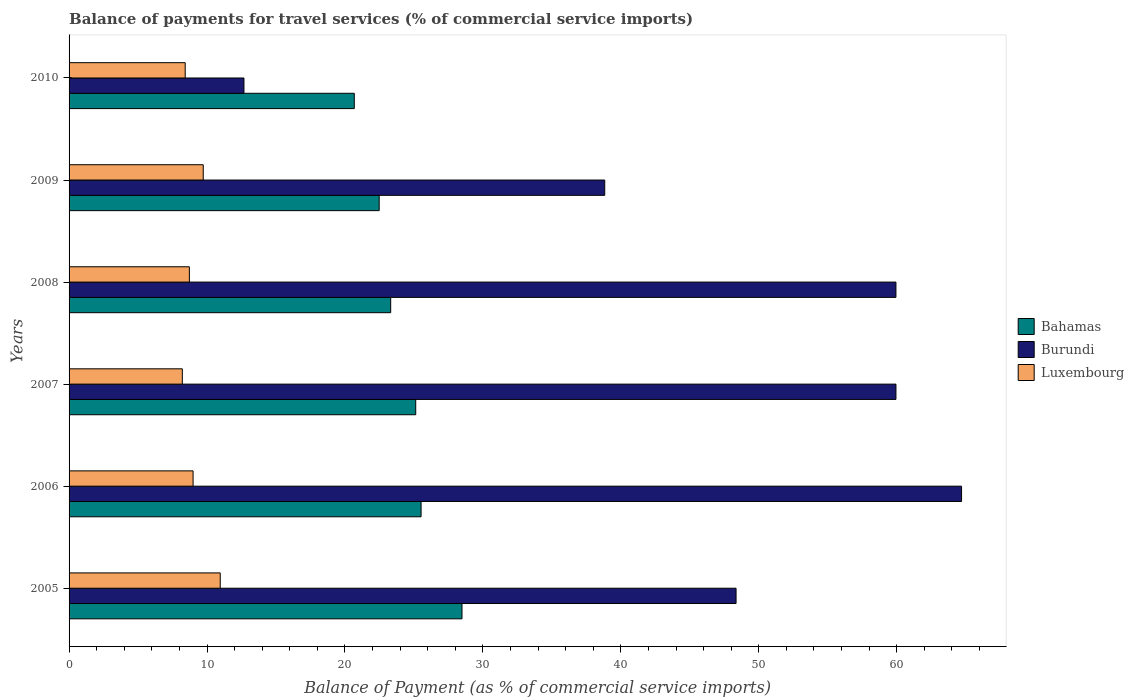How many different coloured bars are there?
Ensure brevity in your answer.  3. Are the number of bars per tick equal to the number of legend labels?
Your answer should be compact. Yes. Are the number of bars on each tick of the Y-axis equal?
Your response must be concise. Yes. How many bars are there on the 4th tick from the bottom?
Your answer should be compact. 3. What is the label of the 3rd group of bars from the top?
Make the answer very short. 2008. In how many cases, is the number of bars for a given year not equal to the number of legend labels?
Provide a succinct answer. 0. What is the balance of payments for travel services in Bahamas in 2005?
Make the answer very short. 28.49. Across all years, what is the maximum balance of payments for travel services in Luxembourg?
Provide a succinct answer. 10.96. Across all years, what is the minimum balance of payments for travel services in Burundi?
Provide a short and direct response. 12.68. What is the total balance of payments for travel services in Luxembourg in the graph?
Make the answer very short. 55.03. What is the difference between the balance of payments for travel services in Bahamas in 2008 and that in 2010?
Offer a very short reply. 2.64. What is the difference between the balance of payments for travel services in Luxembourg in 2010 and the balance of payments for travel services in Bahamas in 2008?
Your answer should be compact. -14.9. What is the average balance of payments for travel services in Luxembourg per year?
Ensure brevity in your answer.  9.17. In the year 2007, what is the difference between the balance of payments for travel services in Bahamas and balance of payments for travel services in Burundi?
Provide a succinct answer. -34.81. In how many years, is the balance of payments for travel services in Luxembourg greater than 40 %?
Your response must be concise. 0. What is the ratio of the balance of payments for travel services in Luxembourg in 2007 to that in 2008?
Provide a short and direct response. 0.94. Is the balance of payments for travel services in Luxembourg in 2005 less than that in 2009?
Make the answer very short. No. Is the difference between the balance of payments for travel services in Bahamas in 2005 and 2008 greater than the difference between the balance of payments for travel services in Burundi in 2005 and 2008?
Ensure brevity in your answer.  Yes. What is the difference between the highest and the second highest balance of payments for travel services in Burundi?
Provide a succinct answer. 4.76. What is the difference between the highest and the lowest balance of payments for travel services in Bahamas?
Provide a short and direct response. 7.81. In how many years, is the balance of payments for travel services in Burundi greater than the average balance of payments for travel services in Burundi taken over all years?
Your answer should be compact. 4. Is the sum of the balance of payments for travel services in Burundi in 2005 and 2006 greater than the maximum balance of payments for travel services in Bahamas across all years?
Make the answer very short. Yes. What does the 1st bar from the top in 2007 represents?
Offer a very short reply. Luxembourg. What does the 3rd bar from the bottom in 2006 represents?
Your answer should be compact. Luxembourg. How many bars are there?
Your answer should be compact. 18. Are the values on the major ticks of X-axis written in scientific E-notation?
Your answer should be compact. No. Does the graph contain any zero values?
Make the answer very short. No. Does the graph contain grids?
Provide a short and direct response. No. Where does the legend appear in the graph?
Give a very brief answer. Center right. How are the legend labels stacked?
Provide a succinct answer. Vertical. What is the title of the graph?
Give a very brief answer. Balance of payments for travel services (% of commercial service imports). Does "Poland" appear as one of the legend labels in the graph?
Keep it short and to the point. No. What is the label or title of the X-axis?
Ensure brevity in your answer.  Balance of Payment (as % of commercial service imports). What is the Balance of Payment (as % of commercial service imports) in Bahamas in 2005?
Your response must be concise. 28.49. What is the Balance of Payment (as % of commercial service imports) of Burundi in 2005?
Your answer should be compact. 48.35. What is the Balance of Payment (as % of commercial service imports) of Luxembourg in 2005?
Give a very brief answer. 10.96. What is the Balance of Payment (as % of commercial service imports) in Bahamas in 2006?
Ensure brevity in your answer.  25.52. What is the Balance of Payment (as % of commercial service imports) in Burundi in 2006?
Give a very brief answer. 64.7. What is the Balance of Payment (as % of commercial service imports) of Luxembourg in 2006?
Provide a succinct answer. 8.99. What is the Balance of Payment (as % of commercial service imports) of Bahamas in 2007?
Offer a very short reply. 25.13. What is the Balance of Payment (as % of commercial service imports) in Burundi in 2007?
Offer a very short reply. 59.95. What is the Balance of Payment (as % of commercial service imports) in Luxembourg in 2007?
Provide a succinct answer. 8.21. What is the Balance of Payment (as % of commercial service imports) of Bahamas in 2008?
Provide a short and direct response. 23.32. What is the Balance of Payment (as % of commercial service imports) in Burundi in 2008?
Give a very brief answer. 59.94. What is the Balance of Payment (as % of commercial service imports) of Luxembourg in 2008?
Keep it short and to the point. 8.72. What is the Balance of Payment (as % of commercial service imports) in Bahamas in 2009?
Provide a short and direct response. 22.48. What is the Balance of Payment (as % of commercial service imports) in Burundi in 2009?
Provide a succinct answer. 38.83. What is the Balance of Payment (as % of commercial service imports) of Luxembourg in 2009?
Your response must be concise. 9.73. What is the Balance of Payment (as % of commercial service imports) in Bahamas in 2010?
Provide a succinct answer. 20.68. What is the Balance of Payment (as % of commercial service imports) of Burundi in 2010?
Your answer should be very brief. 12.68. What is the Balance of Payment (as % of commercial service imports) in Luxembourg in 2010?
Ensure brevity in your answer.  8.42. Across all years, what is the maximum Balance of Payment (as % of commercial service imports) in Bahamas?
Keep it short and to the point. 28.49. Across all years, what is the maximum Balance of Payment (as % of commercial service imports) of Burundi?
Ensure brevity in your answer.  64.7. Across all years, what is the maximum Balance of Payment (as % of commercial service imports) of Luxembourg?
Make the answer very short. 10.96. Across all years, what is the minimum Balance of Payment (as % of commercial service imports) of Bahamas?
Your answer should be compact. 20.68. Across all years, what is the minimum Balance of Payment (as % of commercial service imports) of Burundi?
Give a very brief answer. 12.68. Across all years, what is the minimum Balance of Payment (as % of commercial service imports) of Luxembourg?
Your answer should be very brief. 8.21. What is the total Balance of Payment (as % of commercial service imports) of Bahamas in the graph?
Give a very brief answer. 145.61. What is the total Balance of Payment (as % of commercial service imports) of Burundi in the graph?
Your answer should be compact. 284.46. What is the total Balance of Payment (as % of commercial service imports) in Luxembourg in the graph?
Offer a very short reply. 55.03. What is the difference between the Balance of Payment (as % of commercial service imports) in Bahamas in 2005 and that in 2006?
Make the answer very short. 2.97. What is the difference between the Balance of Payment (as % of commercial service imports) in Burundi in 2005 and that in 2006?
Offer a terse response. -16.35. What is the difference between the Balance of Payment (as % of commercial service imports) of Luxembourg in 2005 and that in 2006?
Offer a very short reply. 1.97. What is the difference between the Balance of Payment (as % of commercial service imports) in Bahamas in 2005 and that in 2007?
Provide a succinct answer. 3.36. What is the difference between the Balance of Payment (as % of commercial service imports) in Burundi in 2005 and that in 2007?
Offer a terse response. -11.59. What is the difference between the Balance of Payment (as % of commercial service imports) in Luxembourg in 2005 and that in 2007?
Give a very brief answer. 2.75. What is the difference between the Balance of Payment (as % of commercial service imports) in Bahamas in 2005 and that in 2008?
Your answer should be compact. 5.17. What is the difference between the Balance of Payment (as % of commercial service imports) in Burundi in 2005 and that in 2008?
Ensure brevity in your answer.  -11.59. What is the difference between the Balance of Payment (as % of commercial service imports) in Luxembourg in 2005 and that in 2008?
Your answer should be very brief. 2.24. What is the difference between the Balance of Payment (as % of commercial service imports) of Bahamas in 2005 and that in 2009?
Your answer should be compact. 6. What is the difference between the Balance of Payment (as % of commercial service imports) of Burundi in 2005 and that in 2009?
Your answer should be compact. 9.52. What is the difference between the Balance of Payment (as % of commercial service imports) in Luxembourg in 2005 and that in 2009?
Make the answer very short. 1.23. What is the difference between the Balance of Payment (as % of commercial service imports) in Bahamas in 2005 and that in 2010?
Provide a succinct answer. 7.81. What is the difference between the Balance of Payment (as % of commercial service imports) of Burundi in 2005 and that in 2010?
Keep it short and to the point. 35.68. What is the difference between the Balance of Payment (as % of commercial service imports) of Luxembourg in 2005 and that in 2010?
Your answer should be very brief. 2.54. What is the difference between the Balance of Payment (as % of commercial service imports) in Bahamas in 2006 and that in 2007?
Provide a succinct answer. 0.39. What is the difference between the Balance of Payment (as % of commercial service imports) in Burundi in 2006 and that in 2007?
Keep it short and to the point. 4.76. What is the difference between the Balance of Payment (as % of commercial service imports) of Luxembourg in 2006 and that in 2007?
Give a very brief answer. 0.78. What is the difference between the Balance of Payment (as % of commercial service imports) of Bahamas in 2006 and that in 2008?
Your answer should be compact. 2.2. What is the difference between the Balance of Payment (as % of commercial service imports) in Burundi in 2006 and that in 2008?
Give a very brief answer. 4.76. What is the difference between the Balance of Payment (as % of commercial service imports) of Luxembourg in 2006 and that in 2008?
Keep it short and to the point. 0.27. What is the difference between the Balance of Payment (as % of commercial service imports) of Bahamas in 2006 and that in 2009?
Give a very brief answer. 3.04. What is the difference between the Balance of Payment (as % of commercial service imports) in Burundi in 2006 and that in 2009?
Your response must be concise. 25.87. What is the difference between the Balance of Payment (as % of commercial service imports) of Luxembourg in 2006 and that in 2009?
Ensure brevity in your answer.  -0.74. What is the difference between the Balance of Payment (as % of commercial service imports) in Bahamas in 2006 and that in 2010?
Provide a short and direct response. 4.84. What is the difference between the Balance of Payment (as % of commercial service imports) of Burundi in 2006 and that in 2010?
Your answer should be very brief. 52.02. What is the difference between the Balance of Payment (as % of commercial service imports) in Luxembourg in 2006 and that in 2010?
Ensure brevity in your answer.  0.57. What is the difference between the Balance of Payment (as % of commercial service imports) in Bahamas in 2007 and that in 2008?
Keep it short and to the point. 1.81. What is the difference between the Balance of Payment (as % of commercial service imports) of Burundi in 2007 and that in 2008?
Your answer should be compact. 0. What is the difference between the Balance of Payment (as % of commercial service imports) in Luxembourg in 2007 and that in 2008?
Provide a short and direct response. -0.51. What is the difference between the Balance of Payment (as % of commercial service imports) of Bahamas in 2007 and that in 2009?
Your answer should be compact. 2.65. What is the difference between the Balance of Payment (as % of commercial service imports) in Burundi in 2007 and that in 2009?
Your response must be concise. 21.11. What is the difference between the Balance of Payment (as % of commercial service imports) in Luxembourg in 2007 and that in 2009?
Provide a succinct answer. -1.51. What is the difference between the Balance of Payment (as % of commercial service imports) of Bahamas in 2007 and that in 2010?
Give a very brief answer. 4.45. What is the difference between the Balance of Payment (as % of commercial service imports) in Burundi in 2007 and that in 2010?
Provide a short and direct response. 47.27. What is the difference between the Balance of Payment (as % of commercial service imports) of Luxembourg in 2007 and that in 2010?
Ensure brevity in your answer.  -0.21. What is the difference between the Balance of Payment (as % of commercial service imports) of Bahamas in 2008 and that in 2009?
Ensure brevity in your answer.  0.83. What is the difference between the Balance of Payment (as % of commercial service imports) in Burundi in 2008 and that in 2009?
Provide a short and direct response. 21.11. What is the difference between the Balance of Payment (as % of commercial service imports) of Luxembourg in 2008 and that in 2009?
Your response must be concise. -1. What is the difference between the Balance of Payment (as % of commercial service imports) in Bahamas in 2008 and that in 2010?
Ensure brevity in your answer.  2.64. What is the difference between the Balance of Payment (as % of commercial service imports) in Burundi in 2008 and that in 2010?
Offer a terse response. 47.27. What is the difference between the Balance of Payment (as % of commercial service imports) of Luxembourg in 2008 and that in 2010?
Provide a short and direct response. 0.3. What is the difference between the Balance of Payment (as % of commercial service imports) of Bahamas in 2009 and that in 2010?
Offer a terse response. 1.81. What is the difference between the Balance of Payment (as % of commercial service imports) in Burundi in 2009 and that in 2010?
Offer a terse response. 26.16. What is the difference between the Balance of Payment (as % of commercial service imports) of Luxembourg in 2009 and that in 2010?
Ensure brevity in your answer.  1.31. What is the difference between the Balance of Payment (as % of commercial service imports) of Bahamas in 2005 and the Balance of Payment (as % of commercial service imports) of Burundi in 2006?
Give a very brief answer. -36.22. What is the difference between the Balance of Payment (as % of commercial service imports) of Bahamas in 2005 and the Balance of Payment (as % of commercial service imports) of Luxembourg in 2006?
Offer a very short reply. 19.5. What is the difference between the Balance of Payment (as % of commercial service imports) of Burundi in 2005 and the Balance of Payment (as % of commercial service imports) of Luxembourg in 2006?
Keep it short and to the point. 39.36. What is the difference between the Balance of Payment (as % of commercial service imports) of Bahamas in 2005 and the Balance of Payment (as % of commercial service imports) of Burundi in 2007?
Ensure brevity in your answer.  -31.46. What is the difference between the Balance of Payment (as % of commercial service imports) in Bahamas in 2005 and the Balance of Payment (as % of commercial service imports) in Luxembourg in 2007?
Provide a short and direct response. 20.27. What is the difference between the Balance of Payment (as % of commercial service imports) of Burundi in 2005 and the Balance of Payment (as % of commercial service imports) of Luxembourg in 2007?
Keep it short and to the point. 40.14. What is the difference between the Balance of Payment (as % of commercial service imports) of Bahamas in 2005 and the Balance of Payment (as % of commercial service imports) of Burundi in 2008?
Give a very brief answer. -31.46. What is the difference between the Balance of Payment (as % of commercial service imports) in Bahamas in 2005 and the Balance of Payment (as % of commercial service imports) in Luxembourg in 2008?
Keep it short and to the point. 19.76. What is the difference between the Balance of Payment (as % of commercial service imports) of Burundi in 2005 and the Balance of Payment (as % of commercial service imports) of Luxembourg in 2008?
Offer a terse response. 39.63. What is the difference between the Balance of Payment (as % of commercial service imports) in Bahamas in 2005 and the Balance of Payment (as % of commercial service imports) in Burundi in 2009?
Ensure brevity in your answer.  -10.35. What is the difference between the Balance of Payment (as % of commercial service imports) of Bahamas in 2005 and the Balance of Payment (as % of commercial service imports) of Luxembourg in 2009?
Provide a succinct answer. 18.76. What is the difference between the Balance of Payment (as % of commercial service imports) of Burundi in 2005 and the Balance of Payment (as % of commercial service imports) of Luxembourg in 2009?
Make the answer very short. 38.63. What is the difference between the Balance of Payment (as % of commercial service imports) in Bahamas in 2005 and the Balance of Payment (as % of commercial service imports) in Burundi in 2010?
Your answer should be very brief. 15.81. What is the difference between the Balance of Payment (as % of commercial service imports) in Bahamas in 2005 and the Balance of Payment (as % of commercial service imports) in Luxembourg in 2010?
Provide a succinct answer. 20.07. What is the difference between the Balance of Payment (as % of commercial service imports) in Burundi in 2005 and the Balance of Payment (as % of commercial service imports) in Luxembourg in 2010?
Make the answer very short. 39.94. What is the difference between the Balance of Payment (as % of commercial service imports) of Bahamas in 2006 and the Balance of Payment (as % of commercial service imports) of Burundi in 2007?
Your answer should be very brief. -34.43. What is the difference between the Balance of Payment (as % of commercial service imports) in Bahamas in 2006 and the Balance of Payment (as % of commercial service imports) in Luxembourg in 2007?
Ensure brevity in your answer.  17.31. What is the difference between the Balance of Payment (as % of commercial service imports) in Burundi in 2006 and the Balance of Payment (as % of commercial service imports) in Luxembourg in 2007?
Offer a terse response. 56.49. What is the difference between the Balance of Payment (as % of commercial service imports) in Bahamas in 2006 and the Balance of Payment (as % of commercial service imports) in Burundi in 2008?
Make the answer very short. -34.42. What is the difference between the Balance of Payment (as % of commercial service imports) of Bahamas in 2006 and the Balance of Payment (as % of commercial service imports) of Luxembourg in 2008?
Your answer should be very brief. 16.8. What is the difference between the Balance of Payment (as % of commercial service imports) of Burundi in 2006 and the Balance of Payment (as % of commercial service imports) of Luxembourg in 2008?
Your answer should be very brief. 55.98. What is the difference between the Balance of Payment (as % of commercial service imports) of Bahamas in 2006 and the Balance of Payment (as % of commercial service imports) of Burundi in 2009?
Your answer should be compact. -13.31. What is the difference between the Balance of Payment (as % of commercial service imports) of Bahamas in 2006 and the Balance of Payment (as % of commercial service imports) of Luxembourg in 2009?
Make the answer very short. 15.79. What is the difference between the Balance of Payment (as % of commercial service imports) in Burundi in 2006 and the Balance of Payment (as % of commercial service imports) in Luxembourg in 2009?
Your answer should be very brief. 54.98. What is the difference between the Balance of Payment (as % of commercial service imports) in Bahamas in 2006 and the Balance of Payment (as % of commercial service imports) in Burundi in 2010?
Keep it short and to the point. 12.84. What is the difference between the Balance of Payment (as % of commercial service imports) of Bahamas in 2006 and the Balance of Payment (as % of commercial service imports) of Luxembourg in 2010?
Ensure brevity in your answer.  17.1. What is the difference between the Balance of Payment (as % of commercial service imports) of Burundi in 2006 and the Balance of Payment (as % of commercial service imports) of Luxembourg in 2010?
Keep it short and to the point. 56.28. What is the difference between the Balance of Payment (as % of commercial service imports) of Bahamas in 2007 and the Balance of Payment (as % of commercial service imports) of Burundi in 2008?
Your answer should be compact. -34.81. What is the difference between the Balance of Payment (as % of commercial service imports) of Bahamas in 2007 and the Balance of Payment (as % of commercial service imports) of Luxembourg in 2008?
Provide a succinct answer. 16.41. What is the difference between the Balance of Payment (as % of commercial service imports) of Burundi in 2007 and the Balance of Payment (as % of commercial service imports) of Luxembourg in 2008?
Your response must be concise. 51.22. What is the difference between the Balance of Payment (as % of commercial service imports) in Bahamas in 2007 and the Balance of Payment (as % of commercial service imports) in Burundi in 2009?
Your answer should be compact. -13.7. What is the difference between the Balance of Payment (as % of commercial service imports) of Bahamas in 2007 and the Balance of Payment (as % of commercial service imports) of Luxembourg in 2009?
Provide a succinct answer. 15.4. What is the difference between the Balance of Payment (as % of commercial service imports) in Burundi in 2007 and the Balance of Payment (as % of commercial service imports) in Luxembourg in 2009?
Provide a succinct answer. 50.22. What is the difference between the Balance of Payment (as % of commercial service imports) of Bahamas in 2007 and the Balance of Payment (as % of commercial service imports) of Burundi in 2010?
Offer a very short reply. 12.45. What is the difference between the Balance of Payment (as % of commercial service imports) of Bahamas in 2007 and the Balance of Payment (as % of commercial service imports) of Luxembourg in 2010?
Offer a very short reply. 16.71. What is the difference between the Balance of Payment (as % of commercial service imports) in Burundi in 2007 and the Balance of Payment (as % of commercial service imports) in Luxembourg in 2010?
Your response must be concise. 51.53. What is the difference between the Balance of Payment (as % of commercial service imports) of Bahamas in 2008 and the Balance of Payment (as % of commercial service imports) of Burundi in 2009?
Your answer should be compact. -15.52. What is the difference between the Balance of Payment (as % of commercial service imports) of Bahamas in 2008 and the Balance of Payment (as % of commercial service imports) of Luxembourg in 2009?
Keep it short and to the point. 13.59. What is the difference between the Balance of Payment (as % of commercial service imports) in Burundi in 2008 and the Balance of Payment (as % of commercial service imports) in Luxembourg in 2009?
Your response must be concise. 50.22. What is the difference between the Balance of Payment (as % of commercial service imports) in Bahamas in 2008 and the Balance of Payment (as % of commercial service imports) in Burundi in 2010?
Offer a very short reply. 10.64. What is the difference between the Balance of Payment (as % of commercial service imports) in Bahamas in 2008 and the Balance of Payment (as % of commercial service imports) in Luxembourg in 2010?
Offer a terse response. 14.9. What is the difference between the Balance of Payment (as % of commercial service imports) in Burundi in 2008 and the Balance of Payment (as % of commercial service imports) in Luxembourg in 2010?
Make the answer very short. 51.52. What is the difference between the Balance of Payment (as % of commercial service imports) in Bahamas in 2009 and the Balance of Payment (as % of commercial service imports) in Burundi in 2010?
Ensure brevity in your answer.  9.8. What is the difference between the Balance of Payment (as % of commercial service imports) of Bahamas in 2009 and the Balance of Payment (as % of commercial service imports) of Luxembourg in 2010?
Provide a succinct answer. 14.06. What is the difference between the Balance of Payment (as % of commercial service imports) in Burundi in 2009 and the Balance of Payment (as % of commercial service imports) in Luxembourg in 2010?
Ensure brevity in your answer.  30.41. What is the average Balance of Payment (as % of commercial service imports) in Bahamas per year?
Offer a terse response. 24.27. What is the average Balance of Payment (as % of commercial service imports) of Burundi per year?
Give a very brief answer. 47.41. What is the average Balance of Payment (as % of commercial service imports) of Luxembourg per year?
Offer a terse response. 9.17. In the year 2005, what is the difference between the Balance of Payment (as % of commercial service imports) of Bahamas and Balance of Payment (as % of commercial service imports) of Burundi?
Provide a succinct answer. -19.87. In the year 2005, what is the difference between the Balance of Payment (as % of commercial service imports) of Bahamas and Balance of Payment (as % of commercial service imports) of Luxembourg?
Ensure brevity in your answer.  17.53. In the year 2005, what is the difference between the Balance of Payment (as % of commercial service imports) of Burundi and Balance of Payment (as % of commercial service imports) of Luxembourg?
Your answer should be very brief. 37.4. In the year 2006, what is the difference between the Balance of Payment (as % of commercial service imports) in Bahamas and Balance of Payment (as % of commercial service imports) in Burundi?
Ensure brevity in your answer.  -39.18. In the year 2006, what is the difference between the Balance of Payment (as % of commercial service imports) of Bahamas and Balance of Payment (as % of commercial service imports) of Luxembourg?
Keep it short and to the point. 16.53. In the year 2006, what is the difference between the Balance of Payment (as % of commercial service imports) of Burundi and Balance of Payment (as % of commercial service imports) of Luxembourg?
Your response must be concise. 55.71. In the year 2007, what is the difference between the Balance of Payment (as % of commercial service imports) in Bahamas and Balance of Payment (as % of commercial service imports) in Burundi?
Your answer should be very brief. -34.81. In the year 2007, what is the difference between the Balance of Payment (as % of commercial service imports) of Bahamas and Balance of Payment (as % of commercial service imports) of Luxembourg?
Provide a short and direct response. 16.92. In the year 2007, what is the difference between the Balance of Payment (as % of commercial service imports) in Burundi and Balance of Payment (as % of commercial service imports) in Luxembourg?
Offer a very short reply. 51.73. In the year 2008, what is the difference between the Balance of Payment (as % of commercial service imports) of Bahamas and Balance of Payment (as % of commercial service imports) of Burundi?
Ensure brevity in your answer.  -36.63. In the year 2008, what is the difference between the Balance of Payment (as % of commercial service imports) of Bahamas and Balance of Payment (as % of commercial service imports) of Luxembourg?
Ensure brevity in your answer.  14.59. In the year 2008, what is the difference between the Balance of Payment (as % of commercial service imports) in Burundi and Balance of Payment (as % of commercial service imports) in Luxembourg?
Provide a succinct answer. 51.22. In the year 2009, what is the difference between the Balance of Payment (as % of commercial service imports) in Bahamas and Balance of Payment (as % of commercial service imports) in Burundi?
Your answer should be very brief. -16.35. In the year 2009, what is the difference between the Balance of Payment (as % of commercial service imports) of Bahamas and Balance of Payment (as % of commercial service imports) of Luxembourg?
Your answer should be compact. 12.76. In the year 2009, what is the difference between the Balance of Payment (as % of commercial service imports) in Burundi and Balance of Payment (as % of commercial service imports) in Luxembourg?
Give a very brief answer. 29.11. In the year 2010, what is the difference between the Balance of Payment (as % of commercial service imports) of Bahamas and Balance of Payment (as % of commercial service imports) of Burundi?
Make the answer very short. 8. In the year 2010, what is the difference between the Balance of Payment (as % of commercial service imports) in Bahamas and Balance of Payment (as % of commercial service imports) in Luxembourg?
Your answer should be very brief. 12.26. In the year 2010, what is the difference between the Balance of Payment (as % of commercial service imports) of Burundi and Balance of Payment (as % of commercial service imports) of Luxembourg?
Provide a succinct answer. 4.26. What is the ratio of the Balance of Payment (as % of commercial service imports) of Bahamas in 2005 to that in 2006?
Give a very brief answer. 1.12. What is the ratio of the Balance of Payment (as % of commercial service imports) in Burundi in 2005 to that in 2006?
Keep it short and to the point. 0.75. What is the ratio of the Balance of Payment (as % of commercial service imports) of Luxembourg in 2005 to that in 2006?
Ensure brevity in your answer.  1.22. What is the ratio of the Balance of Payment (as % of commercial service imports) in Bahamas in 2005 to that in 2007?
Your answer should be compact. 1.13. What is the ratio of the Balance of Payment (as % of commercial service imports) in Burundi in 2005 to that in 2007?
Keep it short and to the point. 0.81. What is the ratio of the Balance of Payment (as % of commercial service imports) of Luxembourg in 2005 to that in 2007?
Offer a very short reply. 1.33. What is the ratio of the Balance of Payment (as % of commercial service imports) in Bahamas in 2005 to that in 2008?
Keep it short and to the point. 1.22. What is the ratio of the Balance of Payment (as % of commercial service imports) of Burundi in 2005 to that in 2008?
Ensure brevity in your answer.  0.81. What is the ratio of the Balance of Payment (as % of commercial service imports) in Luxembourg in 2005 to that in 2008?
Keep it short and to the point. 1.26. What is the ratio of the Balance of Payment (as % of commercial service imports) of Bahamas in 2005 to that in 2009?
Your response must be concise. 1.27. What is the ratio of the Balance of Payment (as % of commercial service imports) in Burundi in 2005 to that in 2009?
Your answer should be compact. 1.25. What is the ratio of the Balance of Payment (as % of commercial service imports) of Luxembourg in 2005 to that in 2009?
Your answer should be very brief. 1.13. What is the ratio of the Balance of Payment (as % of commercial service imports) in Bahamas in 2005 to that in 2010?
Ensure brevity in your answer.  1.38. What is the ratio of the Balance of Payment (as % of commercial service imports) in Burundi in 2005 to that in 2010?
Your answer should be very brief. 3.81. What is the ratio of the Balance of Payment (as % of commercial service imports) in Luxembourg in 2005 to that in 2010?
Give a very brief answer. 1.3. What is the ratio of the Balance of Payment (as % of commercial service imports) of Bahamas in 2006 to that in 2007?
Ensure brevity in your answer.  1.02. What is the ratio of the Balance of Payment (as % of commercial service imports) in Burundi in 2006 to that in 2007?
Your response must be concise. 1.08. What is the ratio of the Balance of Payment (as % of commercial service imports) in Luxembourg in 2006 to that in 2007?
Your answer should be compact. 1.09. What is the ratio of the Balance of Payment (as % of commercial service imports) in Bahamas in 2006 to that in 2008?
Provide a short and direct response. 1.09. What is the ratio of the Balance of Payment (as % of commercial service imports) of Burundi in 2006 to that in 2008?
Provide a succinct answer. 1.08. What is the ratio of the Balance of Payment (as % of commercial service imports) in Luxembourg in 2006 to that in 2008?
Offer a very short reply. 1.03. What is the ratio of the Balance of Payment (as % of commercial service imports) in Bahamas in 2006 to that in 2009?
Keep it short and to the point. 1.14. What is the ratio of the Balance of Payment (as % of commercial service imports) of Burundi in 2006 to that in 2009?
Your answer should be very brief. 1.67. What is the ratio of the Balance of Payment (as % of commercial service imports) in Luxembourg in 2006 to that in 2009?
Ensure brevity in your answer.  0.92. What is the ratio of the Balance of Payment (as % of commercial service imports) in Bahamas in 2006 to that in 2010?
Offer a terse response. 1.23. What is the ratio of the Balance of Payment (as % of commercial service imports) of Burundi in 2006 to that in 2010?
Your answer should be compact. 5.1. What is the ratio of the Balance of Payment (as % of commercial service imports) in Luxembourg in 2006 to that in 2010?
Ensure brevity in your answer.  1.07. What is the ratio of the Balance of Payment (as % of commercial service imports) in Bahamas in 2007 to that in 2008?
Your answer should be compact. 1.08. What is the ratio of the Balance of Payment (as % of commercial service imports) in Luxembourg in 2007 to that in 2008?
Keep it short and to the point. 0.94. What is the ratio of the Balance of Payment (as % of commercial service imports) in Bahamas in 2007 to that in 2009?
Give a very brief answer. 1.12. What is the ratio of the Balance of Payment (as % of commercial service imports) in Burundi in 2007 to that in 2009?
Keep it short and to the point. 1.54. What is the ratio of the Balance of Payment (as % of commercial service imports) in Luxembourg in 2007 to that in 2009?
Offer a very short reply. 0.84. What is the ratio of the Balance of Payment (as % of commercial service imports) in Bahamas in 2007 to that in 2010?
Offer a terse response. 1.22. What is the ratio of the Balance of Payment (as % of commercial service imports) in Burundi in 2007 to that in 2010?
Provide a succinct answer. 4.73. What is the ratio of the Balance of Payment (as % of commercial service imports) of Luxembourg in 2007 to that in 2010?
Provide a short and direct response. 0.98. What is the ratio of the Balance of Payment (as % of commercial service imports) of Bahamas in 2008 to that in 2009?
Your answer should be compact. 1.04. What is the ratio of the Balance of Payment (as % of commercial service imports) of Burundi in 2008 to that in 2009?
Ensure brevity in your answer.  1.54. What is the ratio of the Balance of Payment (as % of commercial service imports) in Luxembourg in 2008 to that in 2009?
Provide a succinct answer. 0.9. What is the ratio of the Balance of Payment (as % of commercial service imports) of Bahamas in 2008 to that in 2010?
Give a very brief answer. 1.13. What is the ratio of the Balance of Payment (as % of commercial service imports) in Burundi in 2008 to that in 2010?
Offer a terse response. 4.73. What is the ratio of the Balance of Payment (as % of commercial service imports) in Luxembourg in 2008 to that in 2010?
Ensure brevity in your answer.  1.04. What is the ratio of the Balance of Payment (as % of commercial service imports) in Bahamas in 2009 to that in 2010?
Make the answer very short. 1.09. What is the ratio of the Balance of Payment (as % of commercial service imports) of Burundi in 2009 to that in 2010?
Offer a very short reply. 3.06. What is the ratio of the Balance of Payment (as % of commercial service imports) in Luxembourg in 2009 to that in 2010?
Keep it short and to the point. 1.16. What is the difference between the highest and the second highest Balance of Payment (as % of commercial service imports) of Bahamas?
Your answer should be compact. 2.97. What is the difference between the highest and the second highest Balance of Payment (as % of commercial service imports) in Burundi?
Give a very brief answer. 4.76. What is the difference between the highest and the second highest Balance of Payment (as % of commercial service imports) of Luxembourg?
Give a very brief answer. 1.23. What is the difference between the highest and the lowest Balance of Payment (as % of commercial service imports) in Bahamas?
Your answer should be compact. 7.81. What is the difference between the highest and the lowest Balance of Payment (as % of commercial service imports) of Burundi?
Your response must be concise. 52.02. What is the difference between the highest and the lowest Balance of Payment (as % of commercial service imports) of Luxembourg?
Give a very brief answer. 2.75. 